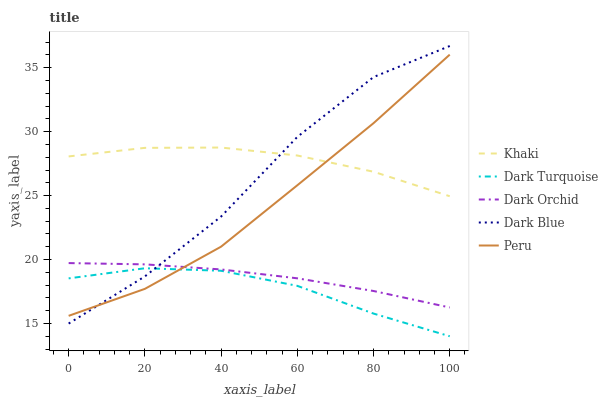Does Dark Turquoise have the minimum area under the curve?
Answer yes or no. Yes. Does Khaki have the maximum area under the curve?
Answer yes or no. Yes. Does Peru have the minimum area under the curve?
Answer yes or no. No. Does Peru have the maximum area under the curve?
Answer yes or no. No. Is Dark Orchid the smoothest?
Answer yes or no. Yes. Is Dark Blue the roughest?
Answer yes or no. Yes. Is Khaki the smoothest?
Answer yes or no. No. Is Khaki the roughest?
Answer yes or no. No. Does Dark Turquoise have the lowest value?
Answer yes or no. Yes. Does Peru have the lowest value?
Answer yes or no. No. Does Dark Blue have the highest value?
Answer yes or no. Yes. Does Khaki have the highest value?
Answer yes or no. No. Is Dark Turquoise less than Khaki?
Answer yes or no. Yes. Is Khaki greater than Dark Turquoise?
Answer yes or no. Yes. Does Peru intersect Dark Turquoise?
Answer yes or no. Yes. Is Peru less than Dark Turquoise?
Answer yes or no. No. Is Peru greater than Dark Turquoise?
Answer yes or no. No. Does Dark Turquoise intersect Khaki?
Answer yes or no. No. 